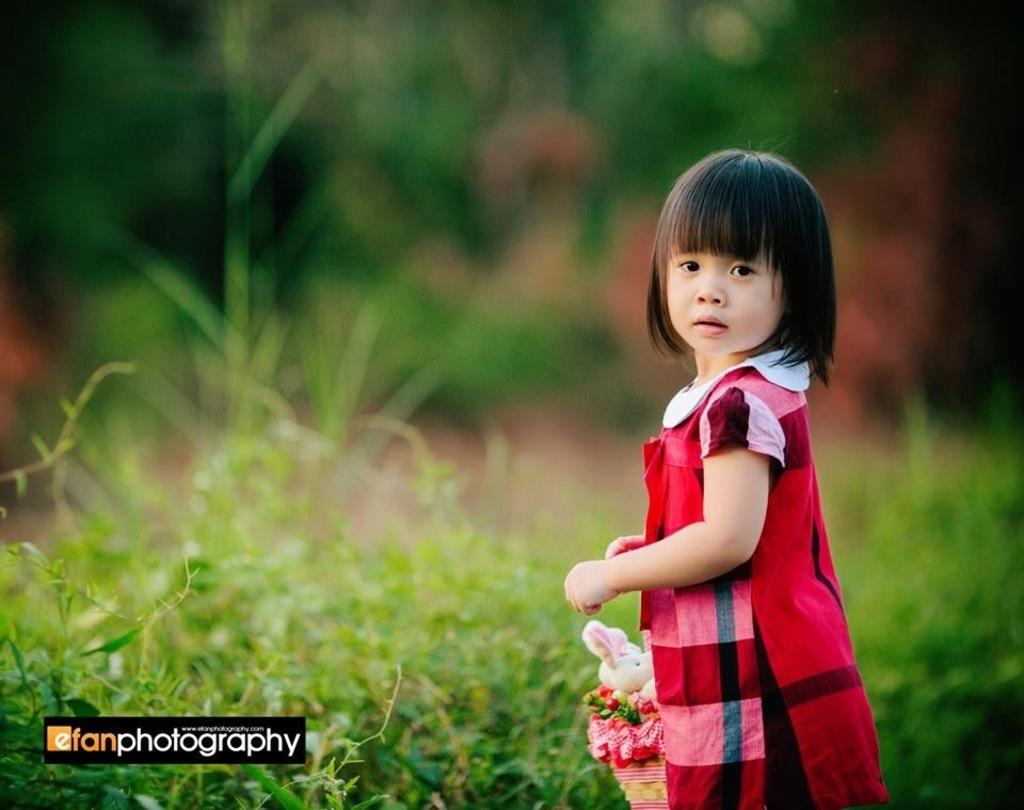Who is the main subject in the image? There is a girl in the image. What is the girl holding in the image? The girl is holding a basket. What is inside the basket? The basket contains toys. What can be seen in the background of the image? There are plants in the background of the image. How would you describe the image's quality? The image is blurred. Where is the spade located in the image? There is no spade present in the image. Who is the girl's uncle in the image? There is no uncle mentioned or depicted in the image. 